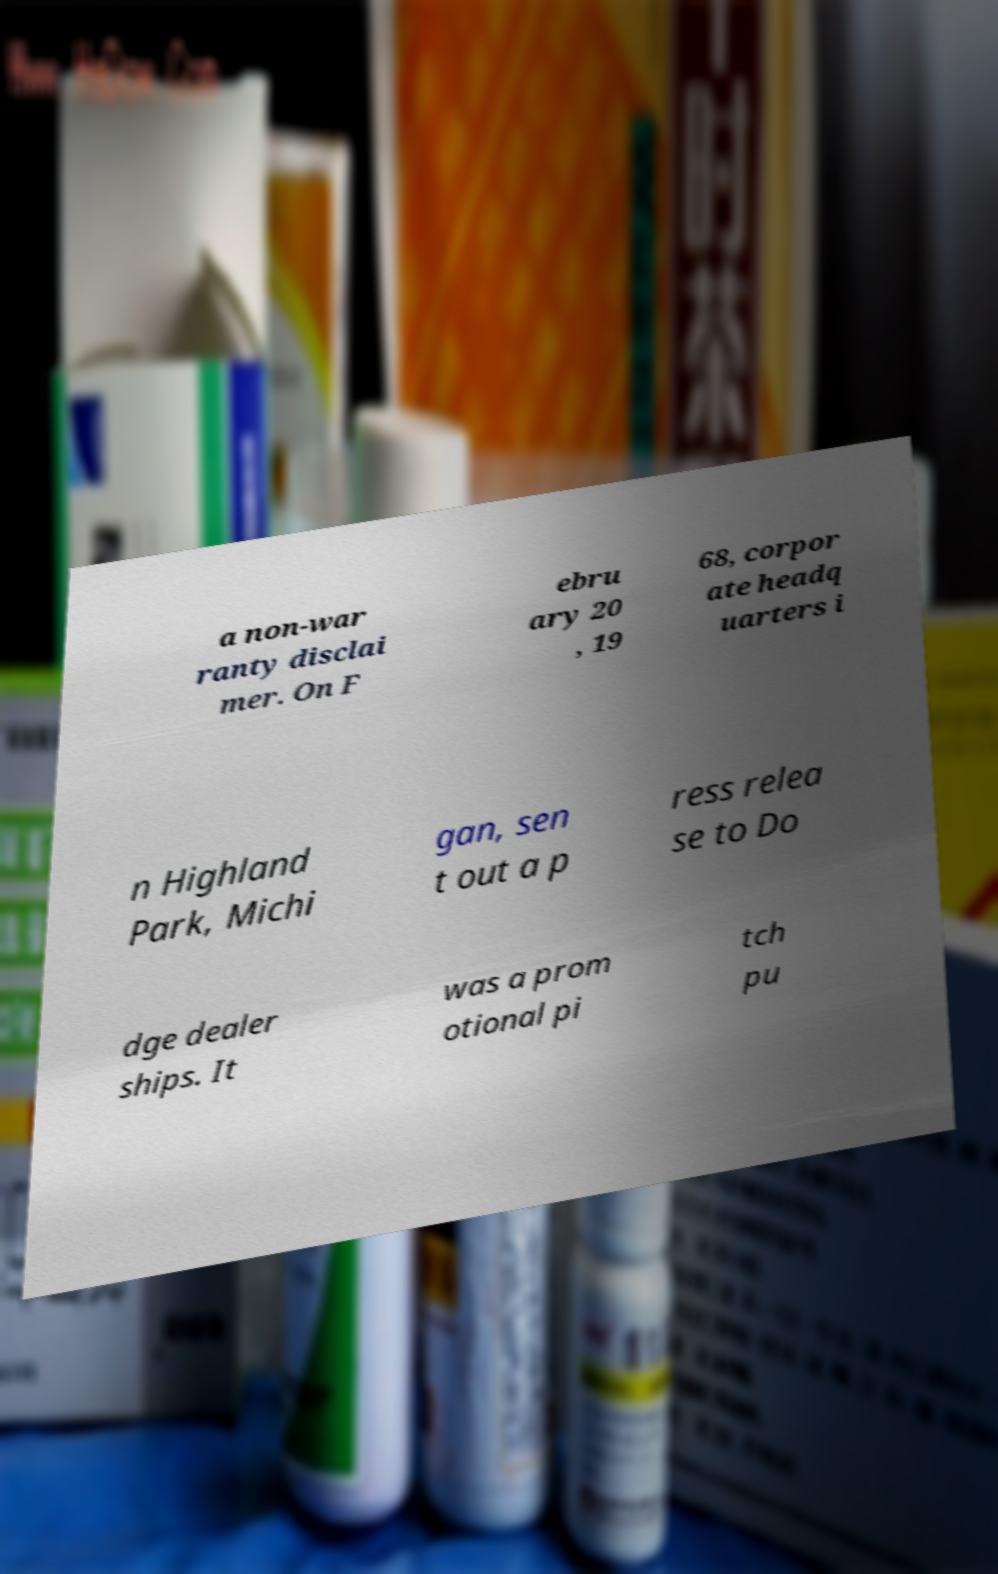Please identify and transcribe the text found in this image. a non-war ranty disclai mer. On F ebru ary 20 , 19 68, corpor ate headq uarters i n Highland Park, Michi gan, sen t out a p ress relea se to Do dge dealer ships. It was a prom otional pi tch pu 